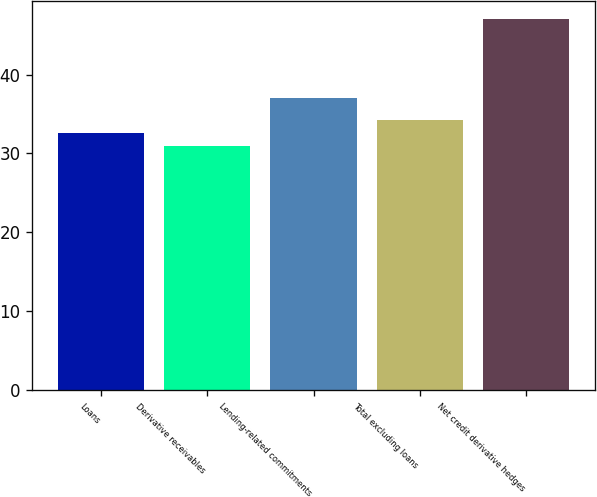<chart> <loc_0><loc_0><loc_500><loc_500><bar_chart><fcel>Loans<fcel>Derivative receivables<fcel>Lending-related commitments<fcel>Total excluding loans<fcel>Net credit derivative hedges<nl><fcel>32.6<fcel>31<fcel>37<fcel>34.2<fcel>47<nl></chart> 